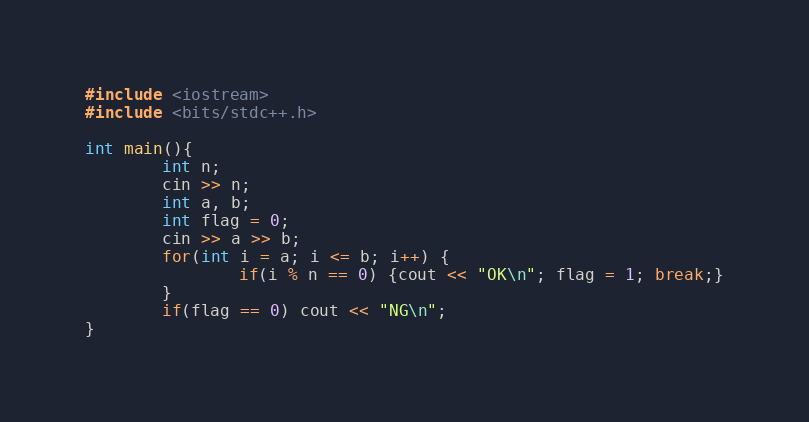Convert code to text. <code><loc_0><loc_0><loc_500><loc_500><_C++_>#include <iostream>
#include <bits/stdc++.h>

int main(){
        int n;
        cin >> n;
        int a, b;
        int flag = 0;
        cin >> a >> b;
        for(int i = a; i <= b; i++) {
                if(i % n == 0) {cout << "OK\n"; flag = 1; break;}
        }
        if(flag == 0) cout << "NG\n";
}
</code> 